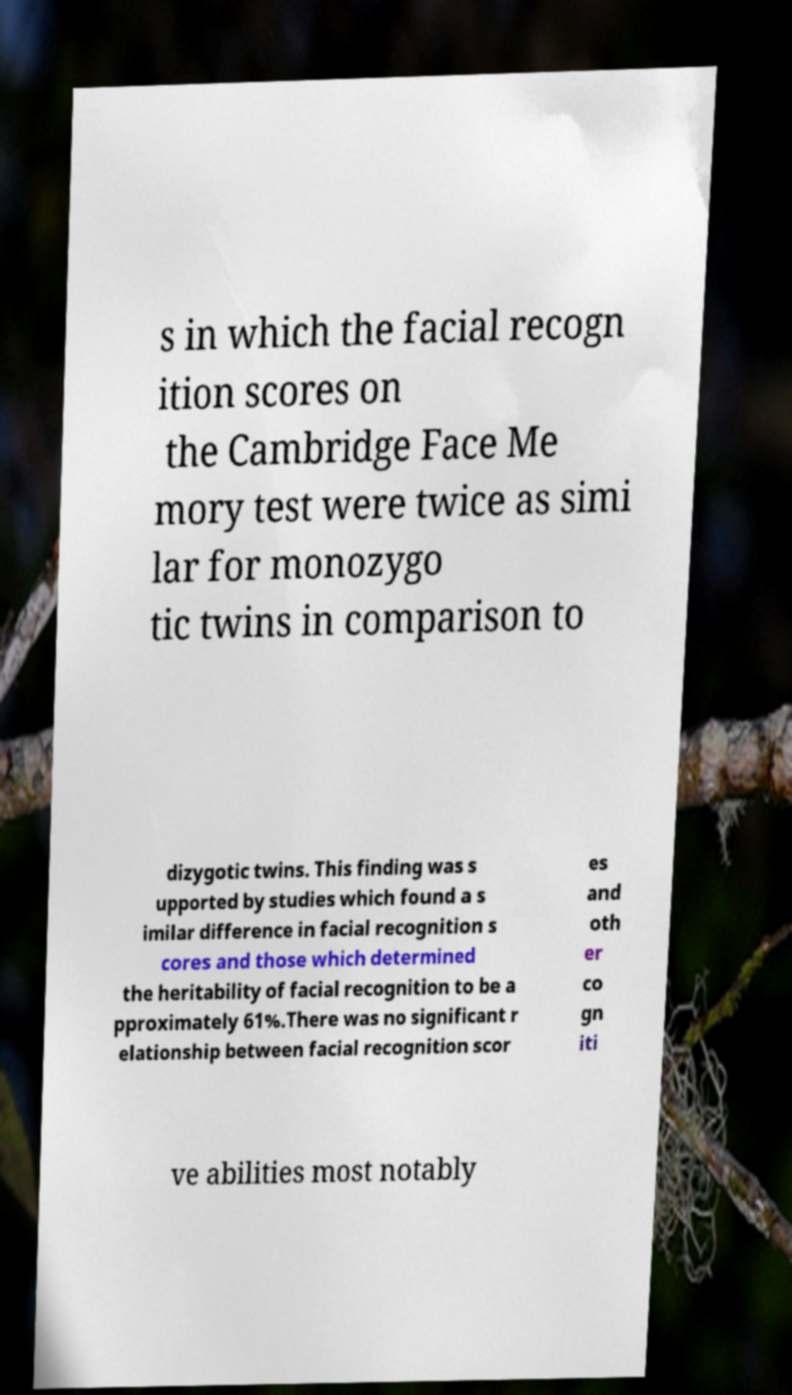What messages or text are displayed in this image? I need them in a readable, typed format. s in which the facial recogn ition scores on the Cambridge Face Me mory test were twice as simi lar for monozygo tic twins in comparison to dizygotic twins. This finding was s upported by studies which found a s imilar difference in facial recognition s cores and those which determined the heritability of facial recognition to be a pproximately 61%.There was no significant r elationship between facial recognition scor es and oth er co gn iti ve abilities most notably 